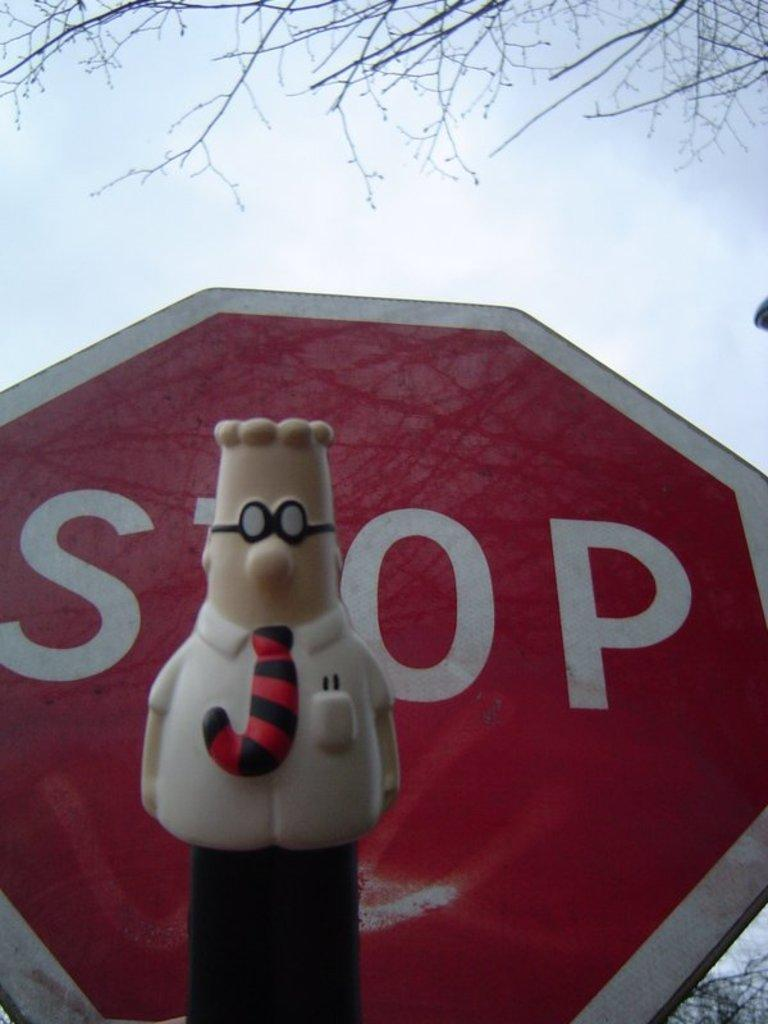What object can be seen in the image that is meant for play or amusement? There is a toy in the image. What is the purpose of the sign board in the image? The purpose of the sign board in the image is not clear from the facts provided. What type of natural elements can be seen in the background of the image? Branches of trees and clouds in the sky are visible in the background of the image. How many insects can be seen crawling on the toy in the image? There is no mention of insects in the image, so it is not possible to determine their presence or quantity. 